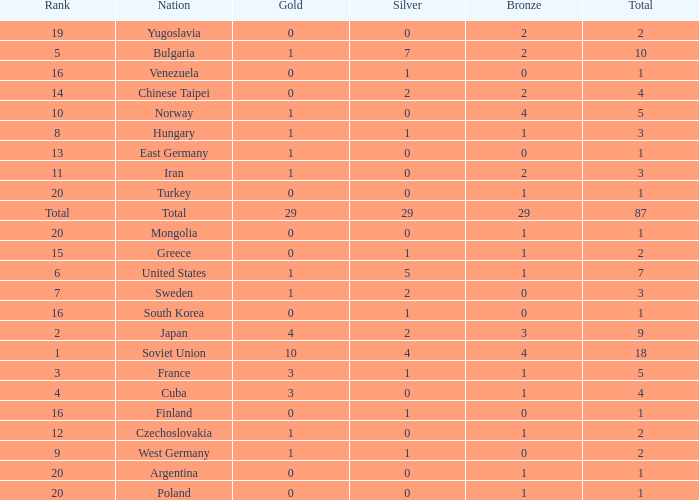What is the average number of bronze medals for total of all nations? 29.0. 